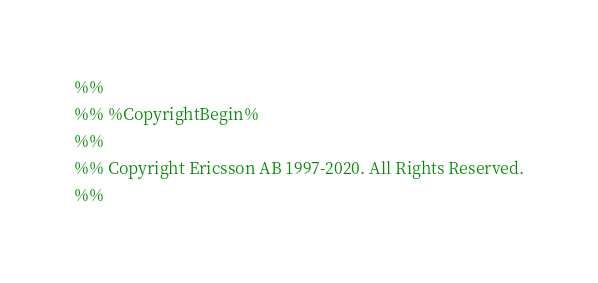<code> <loc_0><loc_0><loc_500><loc_500><_Erlang_>%%
%% %CopyrightBegin%
%%
%% Copyright Ericsson AB 1997-2020. All Rights Reserved.
%%</code> 